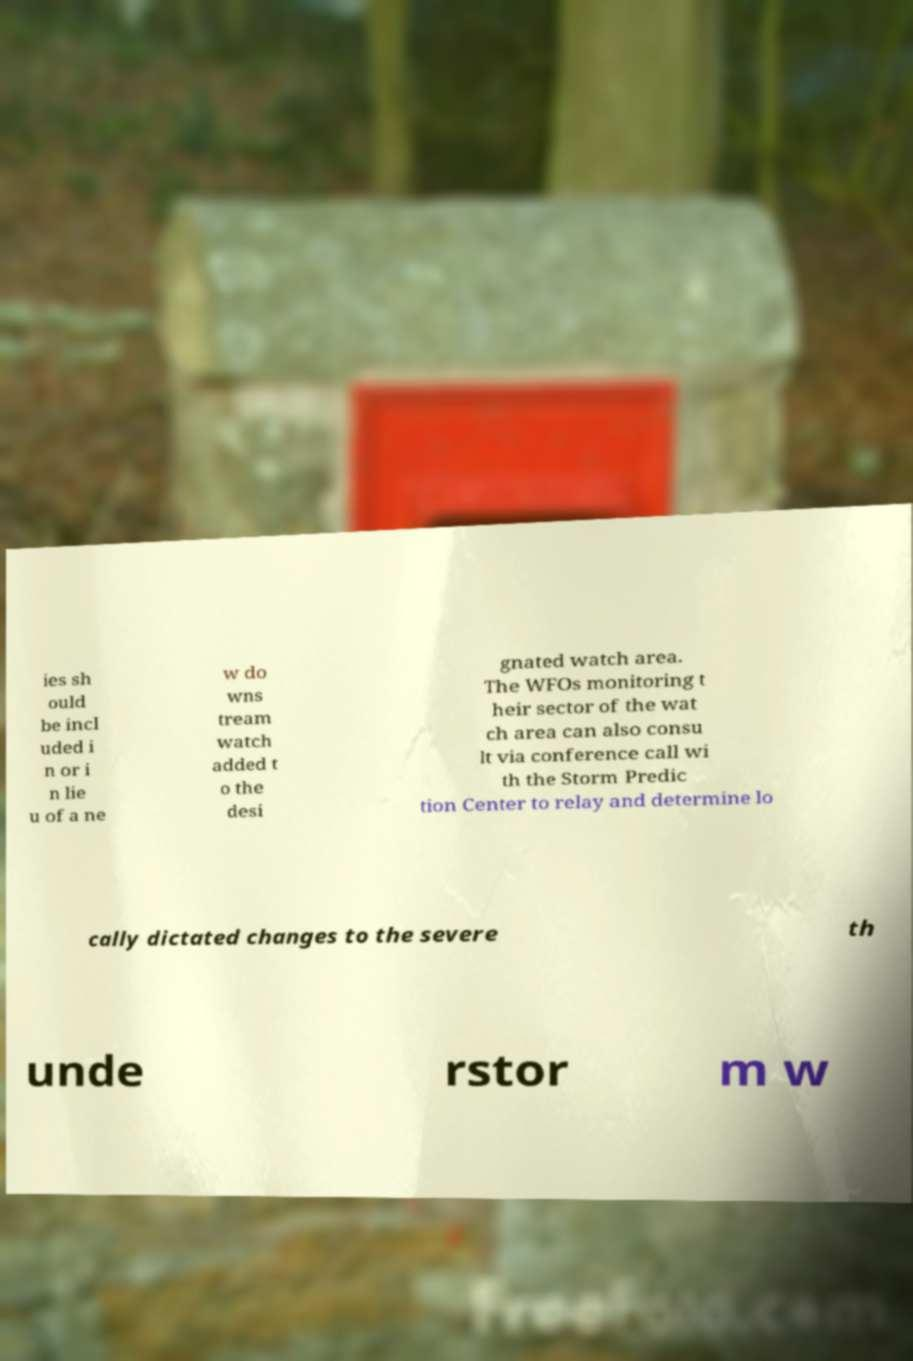Can you accurately transcribe the text from the provided image for me? ies sh ould be incl uded i n or i n lie u of a ne w do wns tream watch added t o the desi gnated watch area. The WFOs monitoring t heir sector of the wat ch area can also consu lt via conference call wi th the Storm Predic tion Center to relay and determine lo cally dictated changes to the severe th unde rstor m w 